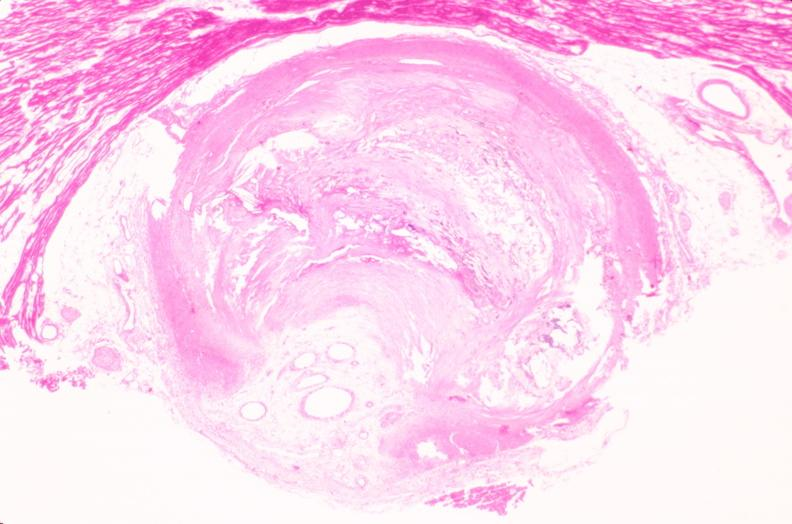what is present?
Answer the question using a single word or phrase. Vasculature 